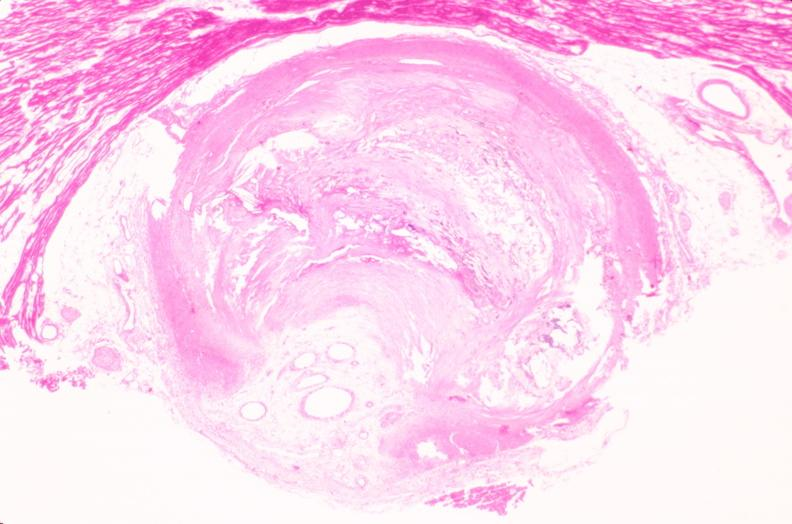what is present?
Answer the question using a single word or phrase. Vasculature 